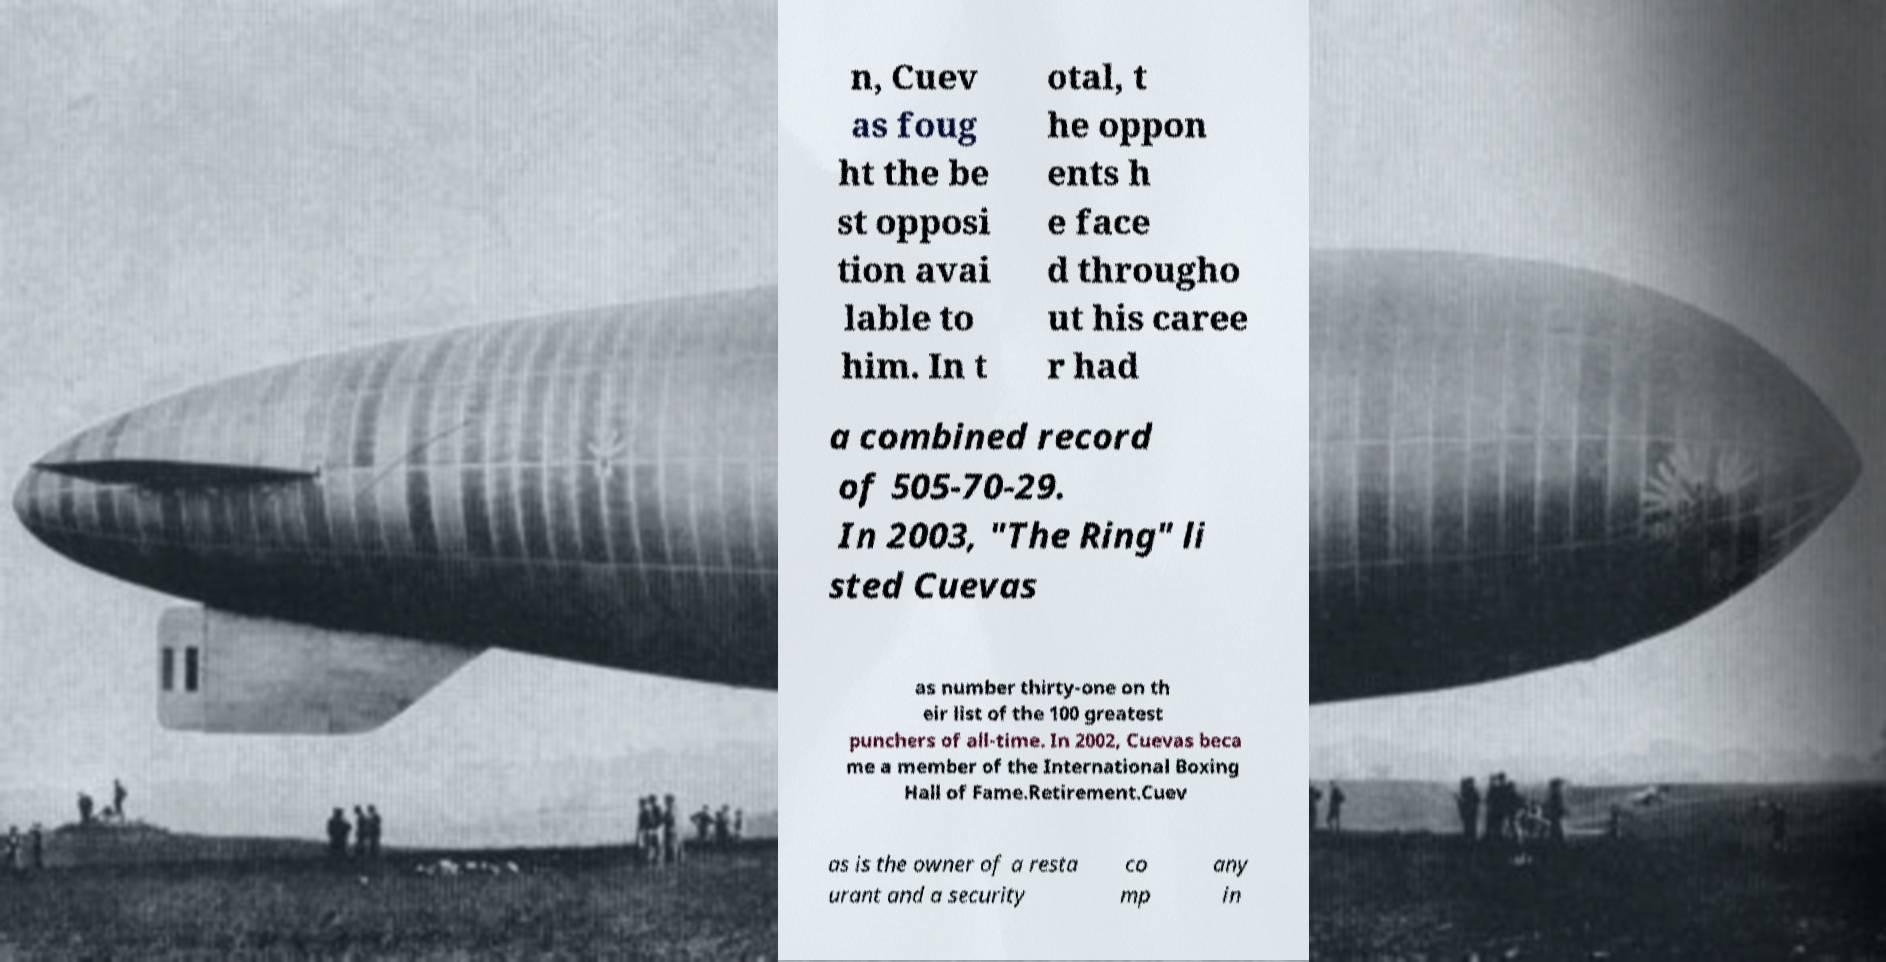Can you accurately transcribe the text from the provided image for me? n, Cuev as foug ht the be st opposi tion avai lable to him. In t otal, t he oppon ents h e face d througho ut his caree r had a combined record of 505-70-29. In 2003, "The Ring" li sted Cuevas as number thirty-one on th eir list of the 100 greatest punchers of all-time. In 2002, Cuevas beca me a member of the International Boxing Hall of Fame.Retirement.Cuev as is the owner of a resta urant and a security co mp any in 